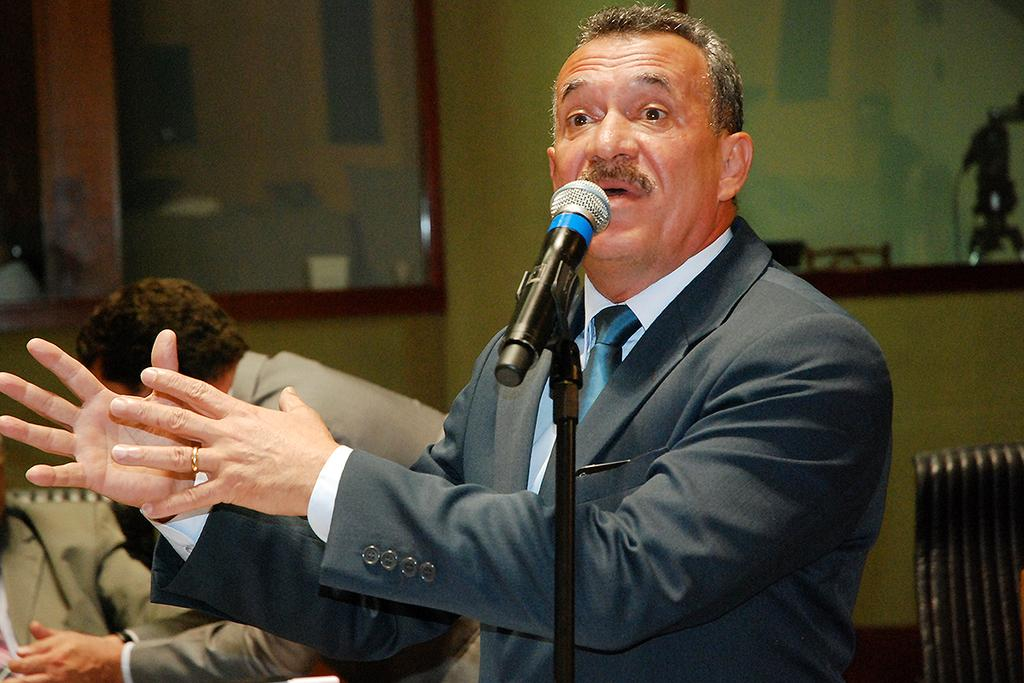Who or what is present in the image? There are people in the image. What are the people wearing? The people are wearing formal dress. What object can be seen in the image that is typically used for amplifying sound? There is a microphone in the image. What type of furniture is visible in the background of the image? There is a chair in the background of the image. What type of cabbage is being sold in the shop depicted in the image? There is no shop or cabbage present in the image; it features people wearing formal dress and a microphone. 